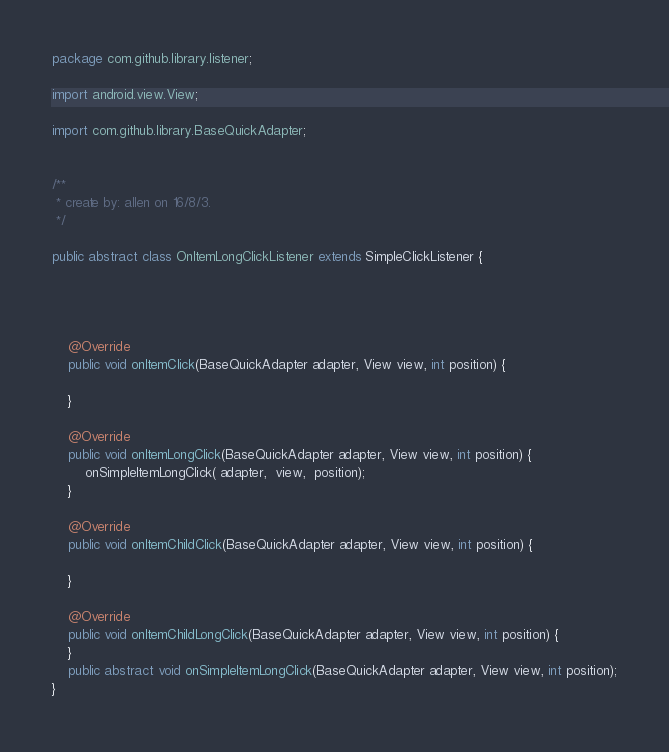Convert code to text. <code><loc_0><loc_0><loc_500><loc_500><_Java_>package com.github.library.listener;

import android.view.View;

import com.github.library.BaseQuickAdapter;


/**
 * create by: allen on 16/8/3.
 */

public abstract class OnItemLongClickListener extends SimpleClickListener {




    @Override
    public void onItemClick(BaseQuickAdapter adapter, View view, int position) {

    }

    @Override
    public void onItemLongClick(BaseQuickAdapter adapter, View view, int position) {
        onSimpleItemLongClick( adapter,  view,  position);
    }

    @Override
    public void onItemChildClick(BaseQuickAdapter adapter, View view, int position) {

    }

    @Override
    public void onItemChildLongClick(BaseQuickAdapter adapter, View view, int position) {
    }
    public abstract void onSimpleItemLongClick(BaseQuickAdapter adapter, View view, int position);
}
</code> 